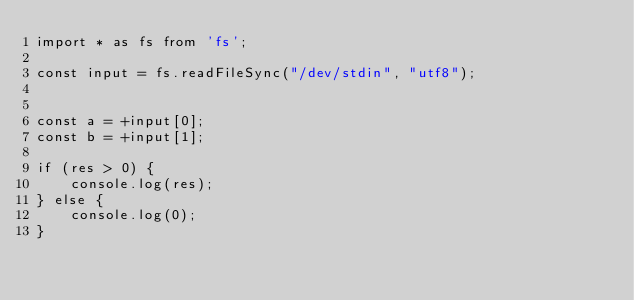Convert code to text. <code><loc_0><loc_0><loc_500><loc_500><_TypeScript_>import * as fs from 'fs';

const input = fs.readFileSync("/dev/stdin", "utf8");


const a = +input[0];
const b = +input[1];

if (res > 0) {
    console.log(res);
} else {
    console.log(0);
}</code> 